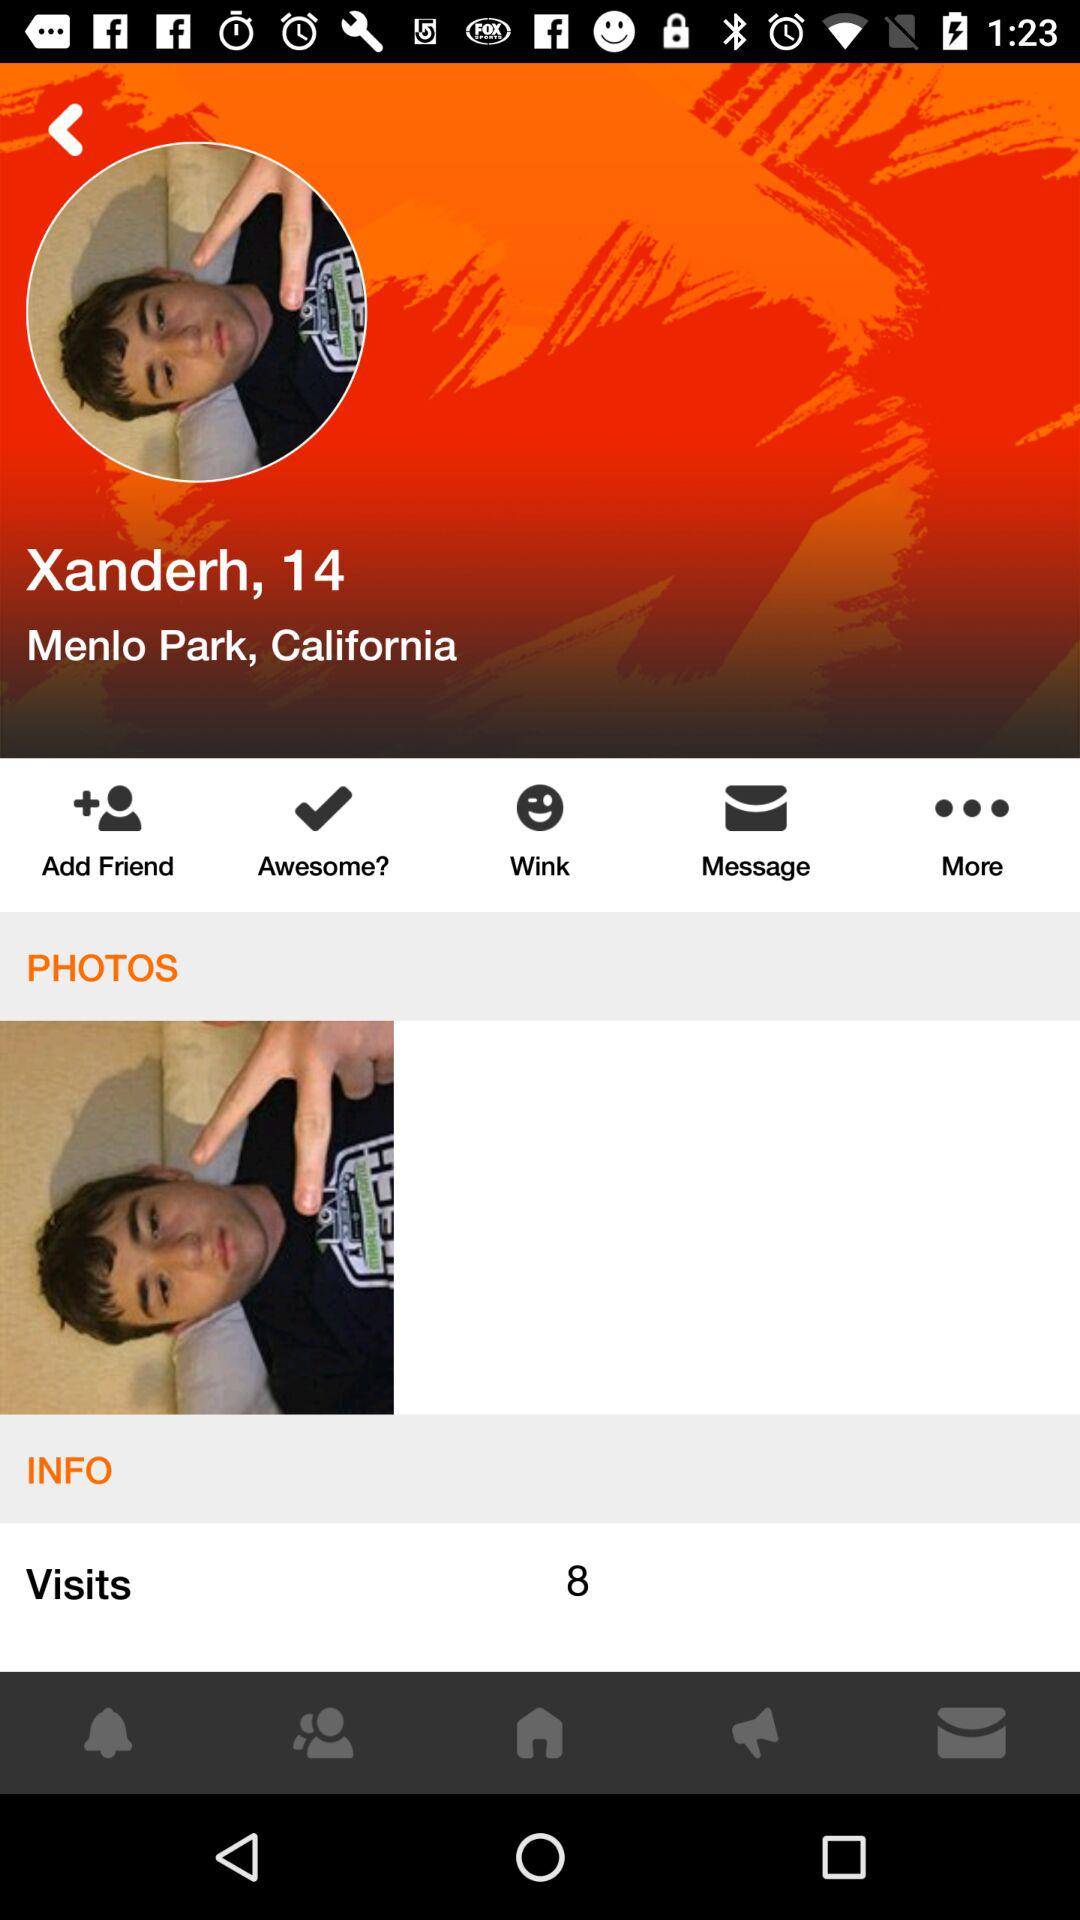What is the age of the user? The age of the user is 14 years. 